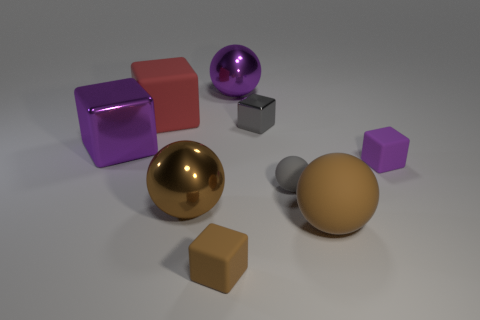Subtract all purple balls. How many balls are left? 3 Subtract all big metallic blocks. How many blocks are left? 4 Subtract all brown cubes. Subtract all blue spheres. How many cubes are left? 4 Subtract all cubes. How many objects are left? 4 Add 4 small purple matte things. How many small purple matte things are left? 5 Add 3 large metal blocks. How many large metal blocks exist? 4 Subtract 2 brown balls. How many objects are left? 7 Subtract all yellow rubber cubes. Subtract all large shiny objects. How many objects are left? 6 